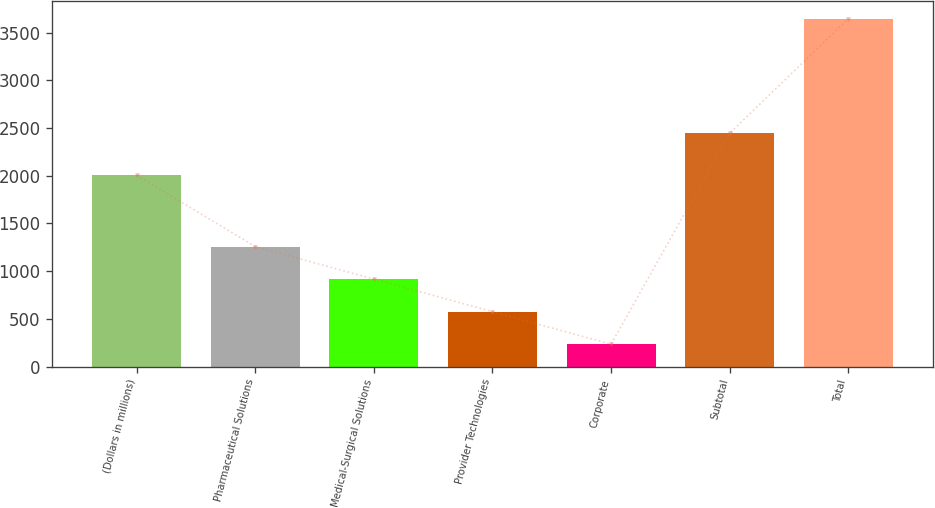Convert chart. <chart><loc_0><loc_0><loc_500><loc_500><bar_chart><fcel>(Dollars in millions)<fcel>Pharmaceutical Solutions<fcel>Medical-Surgical Solutions<fcel>Provider Technologies<fcel>Corporate<fcel>Subtotal<fcel>Total<nl><fcel>2005<fcel>1257.3<fcel>916.2<fcel>575.1<fcel>234<fcel>2445<fcel>3645<nl></chart> 